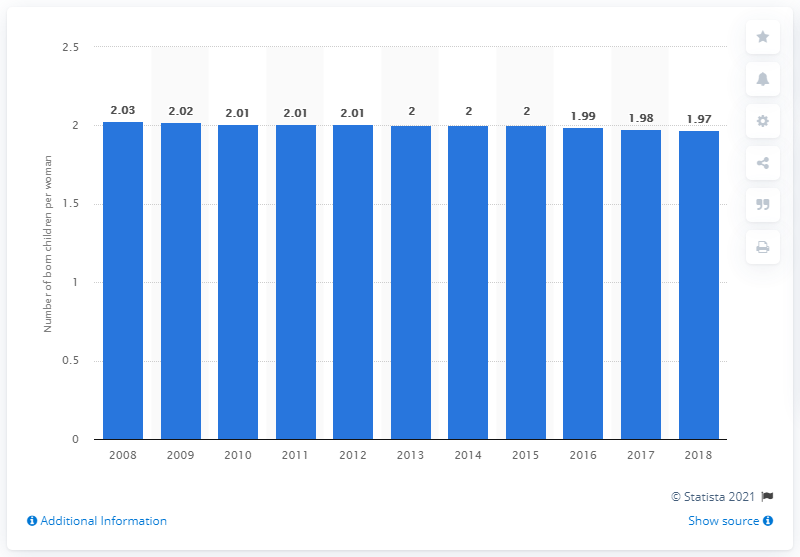Specify some key components in this picture. In 2018, the fertility rate in Uruguay was 1.97 children per woman. 